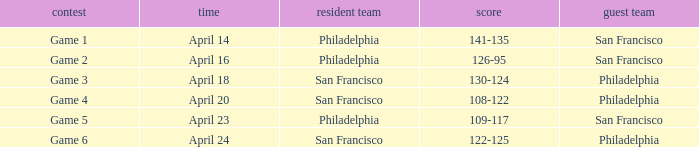Which game had a result of 126-95? Game 2. 